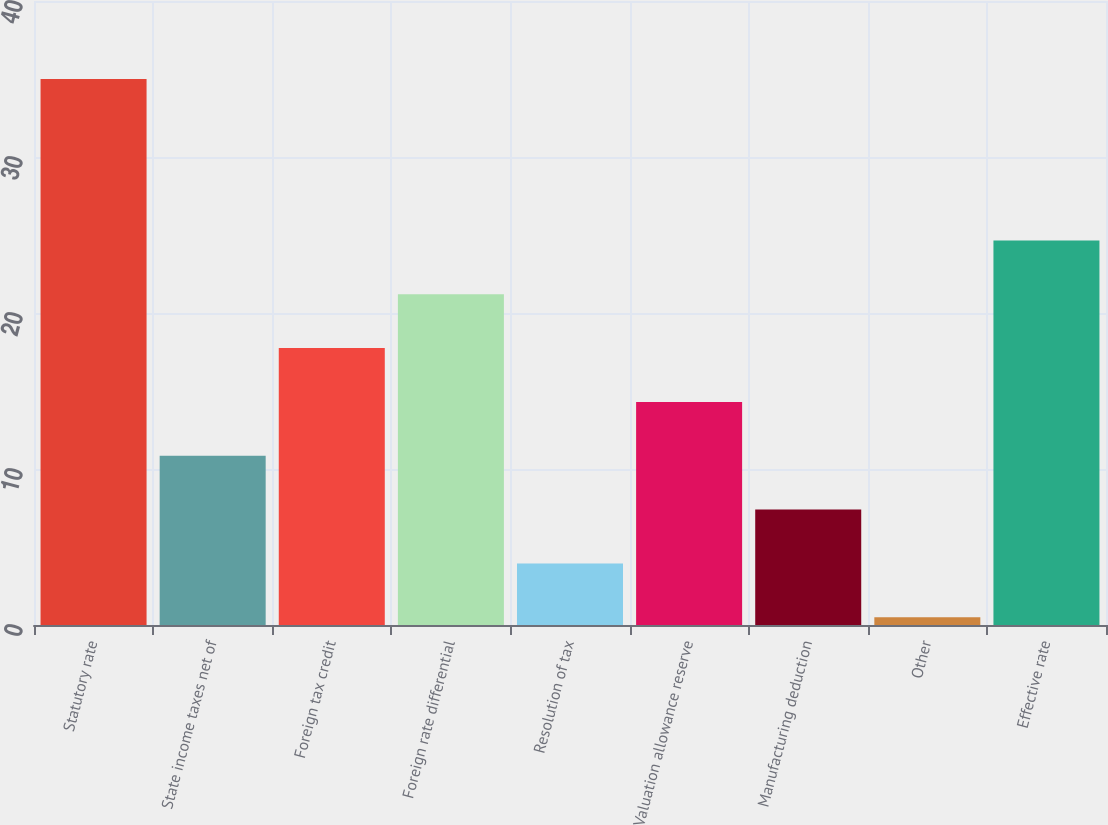<chart> <loc_0><loc_0><loc_500><loc_500><bar_chart><fcel>Statutory rate<fcel>State income taxes net of<fcel>Foreign tax credit<fcel>Foreign rate differential<fcel>Resolution of tax<fcel>Valuation allowance reserve<fcel>Manufacturing deduction<fcel>Other<fcel>Effective rate<nl><fcel>35<fcel>10.85<fcel>17.75<fcel>21.2<fcel>3.95<fcel>14.3<fcel>7.4<fcel>0.5<fcel>24.65<nl></chart> 